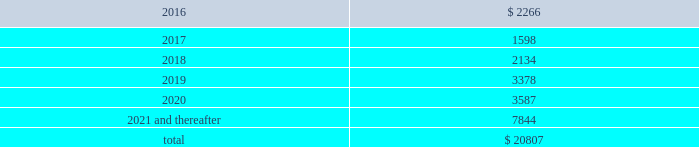Table of contents notes to consolidated financial statements of american airlines group inc .
Secured financings are collateralized by assets , primarily aircraft , engines , simulators , rotable aircraft parts , airport leasehold rights , route authorities and airport slots .
At december 31 , 2015 , the company was operating 35 aircraft under capital leases .
Leases can generally be renewed at rates based on fair market value at the end of the lease term for a number of additional years .
At december 31 , 2015 , the maturities of long-term debt and capital lease obligations are as follows ( in millions ) : .
( a ) 2013 credit facilities on june 27 , 2013 , american and aag entered into a credit and guaranty agreement ( as amended , restated , amended and restated or otherwise modified , the 2013 credit agreement ) with deutsche bank ag new york branch , as administrative agent , and certain lenders that originally provided for a $ 1.9 billion term loan facility scheduled to mature on june 27 , 2019 ( the 2013 term loan facility ) and a $ 1.0 billion revolving credit facility scheduled to mature on june 27 , 2018 ( the 2013 revolving facility ) .
The maturity of the term loan facility was subsequently extended to june 2020 and the revolving credit facility commitments were subsequently increased to $ 1.4 billion with an extended maturity date of october 10 , 2020 , all of which is further described below .
On may 21 , 2015 , american amended and restated the 2013 credit agreement pursuant to which it refinanced the 2013 term loan facility ( the $ 1.9 billion 2015 term loan facility and , together with the 2013 revolving facility , the 2013 credit facilities ) to extend the maturity date to june 2020 and reduce the libor margin from 3.00% ( 3.00 % ) to 2.75% ( 2.75 % ) .
In addition , american entered into certain amendments to reflect the ability for american to make future modifications to the collateral pledged , subject to certain restrictions .
The $ 1.9 billion 2015 term loan facility is repayable in annual installments , with the first installment in an amount equal to 1.25% ( 1.25 % ) of the principal amount commencing on june 27 , 2016 and installments thereafter , in an amount equal to 1.0% ( 1.0 % ) of the principal amount , with any unpaid balance due on the maturity date .
As of december 31 , 2015 , $ 1.9 billion of principal was outstanding under the $ 1.9 billion 2015 term loan facility .
Voluntary prepayments may be made by american at any time .
On october 10 , 2014 , american and aag amended the 2013 credit agreement to extend the maturity date of the 2013 revolving facility to october 10 , 2019 and increased the commitments thereunder to an aggregate principal amount of $ 1.4 billion while reducing the letter of credit commitments thereunder to $ 300 million .
On october 26 , 2015 , american , aag , us airways group and us airways amended the 2013 credit agreement to extend the maturity date of the 2013 revolving facility to october 10 , 2020 .
The 2013 revolving facility provides that american may from time to time borrow , repay and reborrow loans thereunder and have letters of credit issued thereunder .
As of december 31 , 2015 , there were no borrowings or letters of credit outstanding under the 2013 revolving facility .
The 2013 credit facilities bear interest at an index rate plus an applicable index margin or , at american 2019s option , libor ( subject to a floor of 0.75% ( 0.75 % ) , with respect to the $ 1.9 billion 2015 term loan facility ) plus a libor margin of 3.00% ( 3.00 % ) with respect to the 2013 revolving facility and 2.75% ( 2.75 % ) with respect to the $ 1.9 billion 2015 term loan facility ; provided that american 2019s corporate credit rating is ba3 or higher from moody 2019s and bb- or higher from s&p , the applicable libor margin would be 2.50% ( 2.50 % ) for the $ 1.9 billion 2015 term loan .
What percentage of total maturities of long-term debt and capital lease obligations are payable after 2020? 
Computations: (7844 / 20807)
Answer: 0.37699. 